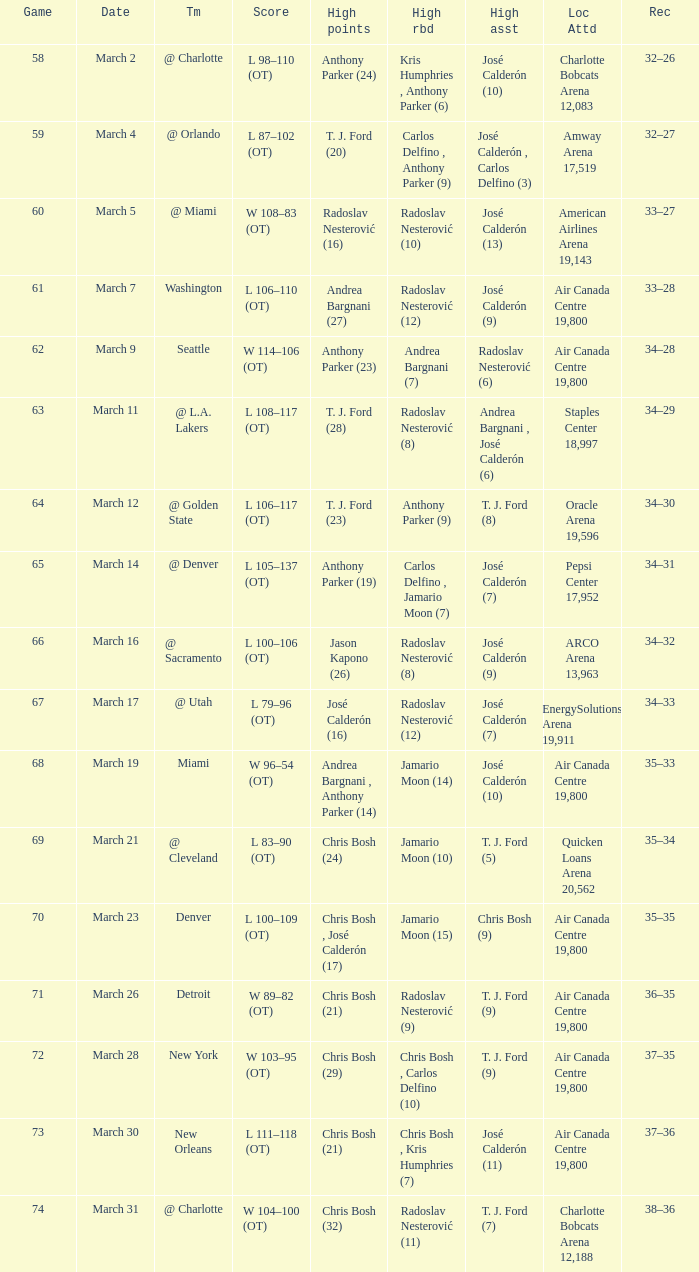What numbered game featured a High rebounds of radoslav nesterović (8), and a High assists of josé calderón (9)? 1.0. 